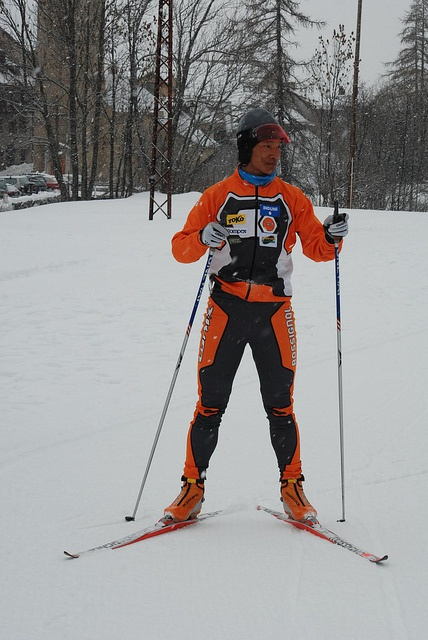Describe the objects in this image and their specific colors. I can see people in black, brown, darkgray, and maroon tones, skis in black, darkgray, brown, and gray tones, car in black, gray, darkgray, and purple tones, car in black, gray, darkgray, and purple tones, and car in black, gray, maroon, and darkgray tones in this image. 